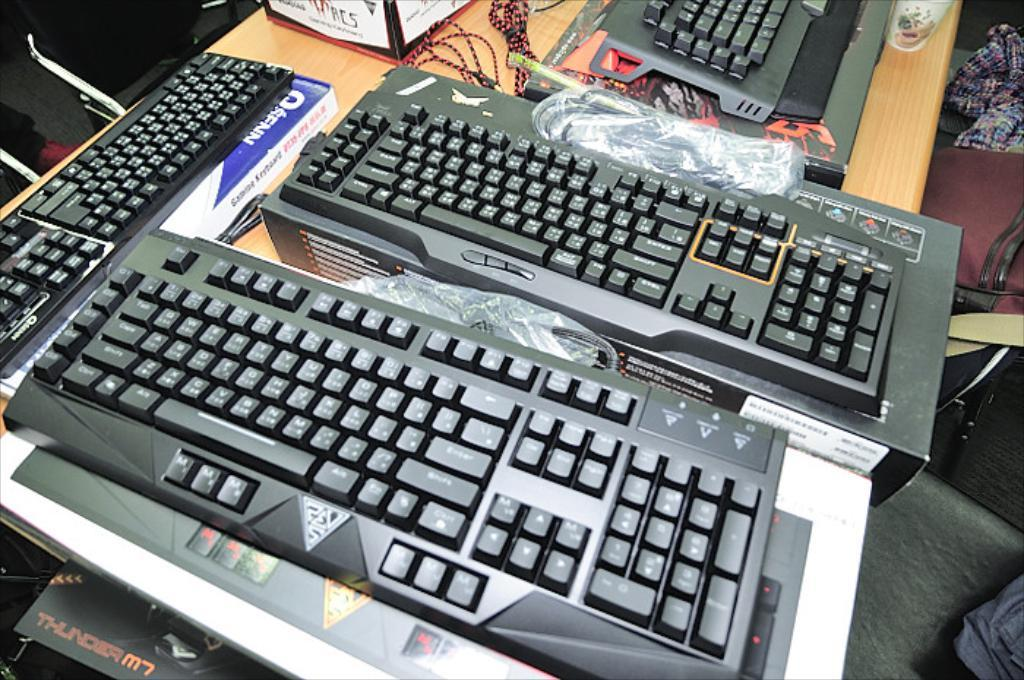Provide a one-sentence caption for the provided image. Several keyboards sit on a table and a box labeled Thunder peeks out from beneath. 